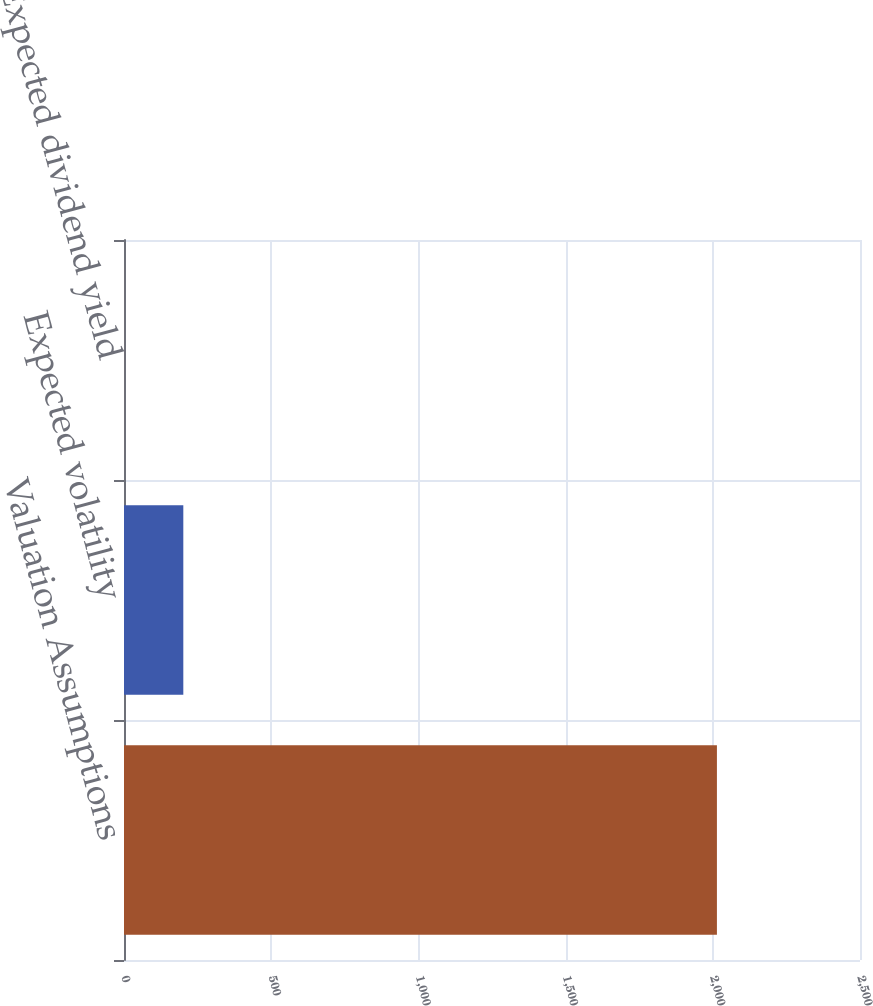Convert chart. <chart><loc_0><loc_0><loc_500><loc_500><bar_chart><fcel>Valuation Assumptions<fcel>Expected volatility<fcel>Expected dividend yield<nl><fcel>2014<fcel>201.47<fcel>0.08<nl></chart> 